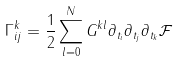Convert formula to latex. <formula><loc_0><loc_0><loc_500><loc_500>\Gamma _ { i j } ^ { k } = \frac { 1 } { 2 } \sum _ { l = 0 } ^ { N } G ^ { k l } \partial _ { t _ { i } } \partial _ { t _ { j } } \partial _ { t _ { k } } \mathcal { F }</formula> 